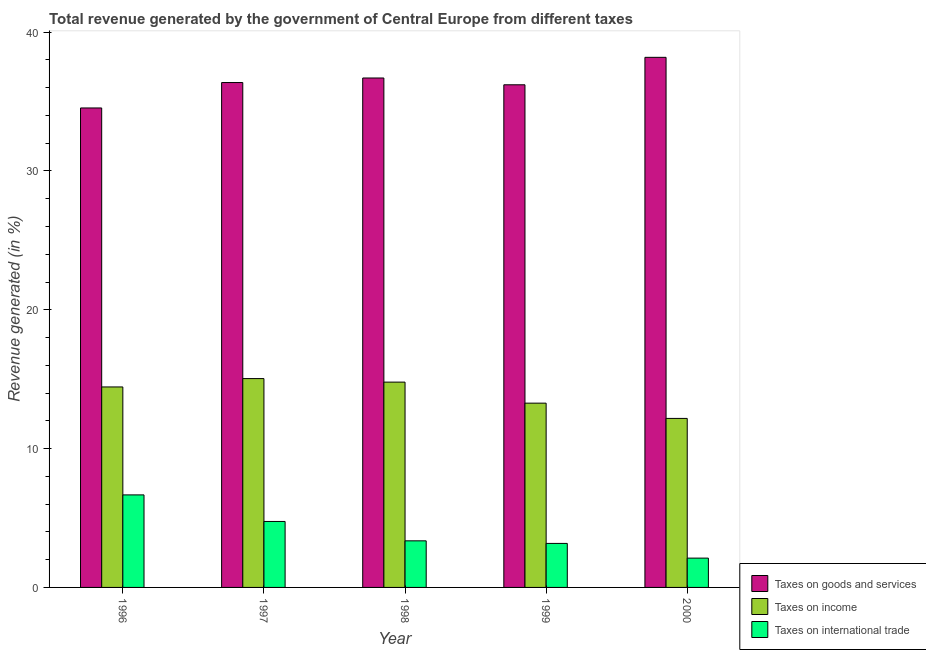How many different coloured bars are there?
Your answer should be compact. 3. Are the number of bars per tick equal to the number of legend labels?
Make the answer very short. Yes. How many bars are there on the 1st tick from the left?
Your answer should be very brief. 3. How many bars are there on the 3rd tick from the right?
Give a very brief answer. 3. What is the percentage of revenue generated by taxes on goods and services in 1996?
Ensure brevity in your answer.  34.54. Across all years, what is the maximum percentage of revenue generated by tax on international trade?
Your answer should be very brief. 6.67. Across all years, what is the minimum percentage of revenue generated by tax on international trade?
Keep it short and to the point. 2.11. In which year was the percentage of revenue generated by taxes on income maximum?
Provide a short and direct response. 1997. What is the total percentage of revenue generated by taxes on income in the graph?
Provide a short and direct response. 69.73. What is the difference between the percentage of revenue generated by taxes on income in 1996 and that in 1998?
Ensure brevity in your answer.  -0.35. What is the difference between the percentage of revenue generated by taxes on income in 1996 and the percentage of revenue generated by taxes on goods and services in 1998?
Keep it short and to the point. -0.35. What is the average percentage of revenue generated by taxes on income per year?
Give a very brief answer. 13.95. What is the ratio of the percentage of revenue generated by taxes on income in 1998 to that in 1999?
Give a very brief answer. 1.11. Is the percentage of revenue generated by taxes on goods and services in 1996 less than that in 2000?
Provide a short and direct response. Yes. What is the difference between the highest and the second highest percentage of revenue generated by taxes on income?
Provide a succinct answer. 0.25. What is the difference between the highest and the lowest percentage of revenue generated by tax on international trade?
Keep it short and to the point. 4.55. In how many years, is the percentage of revenue generated by taxes on income greater than the average percentage of revenue generated by taxes on income taken over all years?
Keep it short and to the point. 3. What does the 2nd bar from the left in 1998 represents?
Your answer should be compact. Taxes on income. What does the 3rd bar from the right in 1996 represents?
Offer a terse response. Taxes on goods and services. Are all the bars in the graph horizontal?
Offer a terse response. No. How many years are there in the graph?
Your response must be concise. 5. Are the values on the major ticks of Y-axis written in scientific E-notation?
Provide a short and direct response. No. Does the graph contain any zero values?
Keep it short and to the point. No. Does the graph contain grids?
Offer a terse response. No. How many legend labels are there?
Your answer should be very brief. 3. What is the title of the graph?
Make the answer very short. Total revenue generated by the government of Central Europe from different taxes. What is the label or title of the Y-axis?
Give a very brief answer. Revenue generated (in %). What is the Revenue generated (in %) in Taxes on goods and services in 1996?
Give a very brief answer. 34.54. What is the Revenue generated (in %) of Taxes on income in 1996?
Provide a succinct answer. 14.44. What is the Revenue generated (in %) of Taxes on international trade in 1996?
Your answer should be very brief. 6.67. What is the Revenue generated (in %) in Taxes on goods and services in 1997?
Make the answer very short. 36.37. What is the Revenue generated (in %) of Taxes on income in 1997?
Your answer should be compact. 15.04. What is the Revenue generated (in %) in Taxes on international trade in 1997?
Make the answer very short. 4.75. What is the Revenue generated (in %) of Taxes on goods and services in 1998?
Keep it short and to the point. 36.7. What is the Revenue generated (in %) in Taxes on income in 1998?
Offer a terse response. 14.79. What is the Revenue generated (in %) in Taxes on international trade in 1998?
Provide a succinct answer. 3.36. What is the Revenue generated (in %) of Taxes on goods and services in 1999?
Provide a succinct answer. 36.21. What is the Revenue generated (in %) in Taxes on income in 1999?
Your answer should be compact. 13.27. What is the Revenue generated (in %) of Taxes on international trade in 1999?
Offer a very short reply. 3.17. What is the Revenue generated (in %) in Taxes on goods and services in 2000?
Keep it short and to the point. 38.19. What is the Revenue generated (in %) in Taxes on income in 2000?
Ensure brevity in your answer.  12.18. What is the Revenue generated (in %) of Taxes on international trade in 2000?
Make the answer very short. 2.11. Across all years, what is the maximum Revenue generated (in %) in Taxes on goods and services?
Offer a very short reply. 38.19. Across all years, what is the maximum Revenue generated (in %) of Taxes on income?
Ensure brevity in your answer.  15.04. Across all years, what is the maximum Revenue generated (in %) in Taxes on international trade?
Offer a very short reply. 6.67. Across all years, what is the minimum Revenue generated (in %) of Taxes on goods and services?
Provide a short and direct response. 34.54. Across all years, what is the minimum Revenue generated (in %) of Taxes on income?
Provide a short and direct response. 12.18. Across all years, what is the minimum Revenue generated (in %) of Taxes on international trade?
Keep it short and to the point. 2.11. What is the total Revenue generated (in %) of Taxes on goods and services in the graph?
Make the answer very short. 182.01. What is the total Revenue generated (in %) of Taxes on income in the graph?
Make the answer very short. 69.73. What is the total Revenue generated (in %) of Taxes on international trade in the graph?
Your response must be concise. 20.06. What is the difference between the Revenue generated (in %) in Taxes on goods and services in 1996 and that in 1997?
Offer a very short reply. -1.83. What is the difference between the Revenue generated (in %) in Taxes on income in 1996 and that in 1997?
Your answer should be very brief. -0.6. What is the difference between the Revenue generated (in %) of Taxes on international trade in 1996 and that in 1997?
Keep it short and to the point. 1.91. What is the difference between the Revenue generated (in %) of Taxes on goods and services in 1996 and that in 1998?
Offer a terse response. -2.16. What is the difference between the Revenue generated (in %) of Taxes on income in 1996 and that in 1998?
Keep it short and to the point. -0.35. What is the difference between the Revenue generated (in %) of Taxes on international trade in 1996 and that in 1998?
Offer a terse response. 3.31. What is the difference between the Revenue generated (in %) in Taxes on goods and services in 1996 and that in 1999?
Your answer should be compact. -1.67. What is the difference between the Revenue generated (in %) of Taxes on income in 1996 and that in 1999?
Give a very brief answer. 1.17. What is the difference between the Revenue generated (in %) in Taxes on international trade in 1996 and that in 1999?
Ensure brevity in your answer.  3.5. What is the difference between the Revenue generated (in %) in Taxes on goods and services in 1996 and that in 2000?
Provide a succinct answer. -3.65. What is the difference between the Revenue generated (in %) in Taxes on income in 1996 and that in 2000?
Give a very brief answer. 2.27. What is the difference between the Revenue generated (in %) in Taxes on international trade in 1996 and that in 2000?
Make the answer very short. 4.55. What is the difference between the Revenue generated (in %) of Taxes on goods and services in 1997 and that in 1998?
Your answer should be very brief. -0.33. What is the difference between the Revenue generated (in %) of Taxes on income in 1997 and that in 1998?
Your answer should be very brief. 0.25. What is the difference between the Revenue generated (in %) of Taxes on international trade in 1997 and that in 1998?
Ensure brevity in your answer.  1.4. What is the difference between the Revenue generated (in %) in Taxes on goods and services in 1997 and that in 1999?
Provide a short and direct response. 0.16. What is the difference between the Revenue generated (in %) of Taxes on income in 1997 and that in 1999?
Provide a short and direct response. 1.77. What is the difference between the Revenue generated (in %) of Taxes on international trade in 1997 and that in 1999?
Give a very brief answer. 1.58. What is the difference between the Revenue generated (in %) in Taxes on goods and services in 1997 and that in 2000?
Your answer should be very brief. -1.82. What is the difference between the Revenue generated (in %) of Taxes on income in 1997 and that in 2000?
Provide a short and direct response. 2.87. What is the difference between the Revenue generated (in %) of Taxes on international trade in 1997 and that in 2000?
Provide a short and direct response. 2.64. What is the difference between the Revenue generated (in %) in Taxes on goods and services in 1998 and that in 1999?
Ensure brevity in your answer.  0.49. What is the difference between the Revenue generated (in %) in Taxes on income in 1998 and that in 1999?
Offer a terse response. 1.52. What is the difference between the Revenue generated (in %) in Taxes on international trade in 1998 and that in 1999?
Give a very brief answer. 0.19. What is the difference between the Revenue generated (in %) of Taxes on goods and services in 1998 and that in 2000?
Your answer should be very brief. -1.49. What is the difference between the Revenue generated (in %) in Taxes on income in 1998 and that in 2000?
Keep it short and to the point. 2.61. What is the difference between the Revenue generated (in %) of Taxes on international trade in 1998 and that in 2000?
Offer a terse response. 1.25. What is the difference between the Revenue generated (in %) in Taxes on goods and services in 1999 and that in 2000?
Make the answer very short. -1.98. What is the difference between the Revenue generated (in %) in Taxes on income in 1999 and that in 2000?
Provide a succinct answer. 1.1. What is the difference between the Revenue generated (in %) in Taxes on international trade in 1999 and that in 2000?
Provide a succinct answer. 1.06. What is the difference between the Revenue generated (in %) in Taxes on goods and services in 1996 and the Revenue generated (in %) in Taxes on income in 1997?
Make the answer very short. 19.5. What is the difference between the Revenue generated (in %) of Taxes on goods and services in 1996 and the Revenue generated (in %) of Taxes on international trade in 1997?
Give a very brief answer. 29.79. What is the difference between the Revenue generated (in %) of Taxes on income in 1996 and the Revenue generated (in %) of Taxes on international trade in 1997?
Provide a succinct answer. 9.69. What is the difference between the Revenue generated (in %) of Taxes on goods and services in 1996 and the Revenue generated (in %) of Taxes on income in 1998?
Your answer should be very brief. 19.75. What is the difference between the Revenue generated (in %) in Taxes on goods and services in 1996 and the Revenue generated (in %) in Taxes on international trade in 1998?
Make the answer very short. 31.18. What is the difference between the Revenue generated (in %) of Taxes on income in 1996 and the Revenue generated (in %) of Taxes on international trade in 1998?
Ensure brevity in your answer.  11.09. What is the difference between the Revenue generated (in %) of Taxes on goods and services in 1996 and the Revenue generated (in %) of Taxes on income in 1999?
Your answer should be compact. 21.27. What is the difference between the Revenue generated (in %) in Taxes on goods and services in 1996 and the Revenue generated (in %) in Taxes on international trade in 1999?
Provide a succinct answer. 31.37. What is the difference between the Revenue generated (in %) in Taxes on income in 1996 and the Revenue generated (in %) in Taxes on international trade in 1999?
Your answer should be very brief. 11.27. What is the difference between the Revenue generated (in %) in Taxes on goods and services in 1996 and the Revenue generated (in %) in Taxes on income in 2000?
Your answer should be compact. 22.36. What is the difference between the Revenue generated (in %) in Taxes on goods and services in 1996 and the Revenue generated (in %) in Taxes on international trade in 2000?
Make the answer very short. 32.43. What is the difference between the Revenue generated (in %) in Taxes on income in 1996 and the Revenue generated (in %) in Taxes on international trade in 2000?
Give a very brief answer. 12.33. What is the difference between the Revenue generated (in %) of Taxes on goods and services in 1997 and the Revenue generated (in %) of Taxes on income in 1998?
Offer a very short reply. 21.58. What is the difference between the Revenue generated (in %) in Taxes on goods and services in 1997 and the Revenue generated (in %) in Taxes on international trade in 1998?
Ensure brevity in your answer.  33.01. What is the difference between the Revenue generated (in %) of Taxes on income in 1997 and the Revenue generated (in %) of Taxes on international trade in 1998?
Provide a succinct answer. 11.69. What is the difference between the Revenue generated (in %) of Taxes on goods and services in 1997 and the Revenue generated (in %) of Taxes on income in 1999?
Keep it short and to the point. 23.1. What is the difference between the Revenue generated (in %) of Taxes on goods and services in 1997 and the Revenue generated (in %) of Taxes on international trade in 1999?
Your response must be concise. 33.2. What is the difference between the Revenue generated (in %) in Taxes on income in 1997 and the Revenue generated (in %) in Taxes on international trade in 1999?
Ensure brevity in your answer.  11.87. What is the difference between the Revenue generated (in %) in Taxes on goods and services in 1997 and the Revenue generated (in %) in Taxes on income in 2000?
Offer a terse response. 24.2. What is the difference between the Revenue generated (in %) of Taxes on goods and services in 1997 and the Revenue generated (in %) of Taxes on international trade in 2000?
Provide a succinct answer. 34.26. What is the difference between the Revenue generated (in %) of Taxes on income in 1997 and the Revenue generated (in %) of Taxes on international trade in 2000?
Make the answer very short. 12.93. What is the difference between the Revenue generated (in %) in Taxes on goods and services in 1998 and the Revenue generated (in %) in Taxes on income in 1999?
Your answer should be very brief. 23.42. What is the difference between the Revenue generated (in %) of Taxes on goods and services in 1998 and the Revenue generated (in %) of Taxes on international trade in 1999?
Give a very brief answer. 33.53. What is the difference between the Revenue generated (in %) of Taxes on income in 1998 and the Revenue generated (in %) of Taxes on international trade in 1999?
Make the answer very short. 11.62. What is the difference between the Revenue generated (in %) in Taxes on goods and services in 1998 and the Revenue generated (in %) in Taxes on income in 2000?
Offer a terse response. 24.52. What is the difference between the Revenue generated (in %) in Taxes on goods and services in 1998 and the Revenue generated (in %) in Taxes on international trade in 2000?
Keep it short and to the point. 34.59. What is the difference between the Revenue generated (in %) in Taxes on income in 1998 and the Revenue generated (in %) in Taxes on international trade in 2000?
Offer a very short reply. 12.68. What is the difference between the Revenue generated (in %) of Taxes on goods and services in 1999 and the Revenue generated (in %) of Taxes on income in 2000?
Make the answer very short. 24.03. What is the difference between the Revenue generated (in %) in Taxes on goods and services in 1999 and the Revenue generated (in %) in Taxes on international trade in 2000?
Give a very brief answer. 34.1. What is the difference between the Revenue generated (in %) of Taxes on income in 1999 and the Revenue generated (in %) of Taxes on international trade in 2000?
Provide a succinct answer. 11.16. What is the average Revenue generated (in %) of Taxes on goods and services per year?
Your response must be concise. 36.4. What is the average Revenue generated (in %) of Taxes on income per year?
Your response must be concise. 13.95. What is the average Revenue generated (in %) of Taxes on international trade per year?
Make the answer very short. 4.01. In the year 1996, what is the difference between the Revenue generated (in %) in Taxes on goods and services and Revenue generated (in %) in Taxes on income?
Your answer should be very brief. 20.1. In the year 1996, what is the difference between the Revenue generated (in %) in Taxes on goods and services and Revenue generated (in %) in Taxes on international trade?
Ensure brevity in your answer.  27.87. In the year 1996, what is the difference between the Revenue generated (in %) in Taxes on income and Revenue generated (in %) in Taxes on international trade?
Your answer should be compact. 7.78. In the year 1997, what is the difference between the Revenue generated (in %) of Taxes on goods and services and Revenue generated (in %) of Taxes on income?
Give a very brief answer. 21.33. In the year 1997, what is the difference between the Revenue generated (in %) of Taxes on goods and services and Revenue generated (in %) of Taxes on international trade?
Your answer should be compact. 31.62. In the year 1997, what is the difference between the Revenue generated (in %) in Taxes on income and Revenue generated (in %) in Taxes on international trade?
Provide a succinct answer. 10.29. In the year 1998, what is the difference between the Revenue generated (in %) of Taxes on goods and services and Revenue generated (in %) of Taxes on income?
Offer a very short reply. 21.91. In the year 1998, what is the difference between the Revenue generated (in %) in Taxes on goods and services and Revenue generated (in %) in Taxes on international trade?
Provide a short and direct response. 33.34. In the year 1998, what is the difference between the Revenue generated (in %) of Taxes on income and Revenue generated (in %) of Taxes on international trade?
Offer a terse response. 11.43. In the year 1999, what is the difference between the Revenue generated (in %) of Taxes on goods and services and Revenue generated (in %) of Taxes on income?
Your answer should be very brief. 22.93. In the year 1999, what is the difference between the Revenue generated (in %) in Taxes on goods and services and Revenue generated (in %) in Taxes on international trade?
Make the answer very short. 33.04. In the year 1999, what is the difference between the Revenue generated (in %) of Taxes on income and Revenue generated (in %) of Taxes on international trade?
Offer a terse response. 10.1. In the year 2000, what is the difference between the Revenue generated (in %) in Taxes on goods and services and Revenue generated (in %) in Taxes on income?
Make the answer very short. 26.01. In the year 2000, what is the difference between the Revenue generated (in %) in Taxes on goods and services and Revenue generated (in %) in Taxes on international trade?
Your answer should be very brief. 36.08. In the year 2000, what is the difference between the Revenue generated (in %) of Taxes on income and Revenue generated (in %) of Taxes on international trade?
Give a very brief answer. 10.06. What is the ratio of the Revenue generated (in %) in Taxes on goods and services in 1996 to that in 1997?
Provide a succinct answer. 0.95. What is the ratio of the Revenue generated (in %) in Taxes on international trade in 1996 to that in 1997?
Your answer should be compact. 1.4. What is the ratio of the Revenue generated (in %) in Taxes on income in 1996 to that in 1998?
Provide a short and direct response. 0.98. What is the ratio of the Revenue generated (in %) of Taxes on international trade in 1996 to that in 1998?
Provide a succinct answer. 1.99. What is the ratio of the Revenue generated (in %) in Taxes on goods and services in 1996 to that in 1999?
Ensure brevity in your answer.  0.95. What is the ratio of the Revenue generated (in %) of Taxes on income in 1996 to that in 1999?
Keep it short and to the point. 1.09. What is the ratio of the Revenue generated (in %) in Taxes on international trade in 1996 to that in 1999?
Give a very brief answer. 2.1. What is the ratio of the Revenue generated (in %) in Taxes on goods and services in 1996 to that in 2000?
Your answer should be compact. 0.9. What is the ratio of the Revenue generated (in %) of Taxes on income in 1996 to that in 2000?
Your answer should be compact. 1.19. What is the ratio of the Revenue generated (in %) in Taxes on international trade in 1996 to that in 2000?
Make the answer very short. 3.16. What is the ratio of the Revenue generated (in %) in Taxes on goods and services in 1997 to that in 1998?
Your response must be concise. 0.99. What is the ratio of the Revenue generated (in %) in Taxes on income in 1997 to that in 1998?
Offer a terse response. 1.02. What is the ratio of the Revenue generated (in %) in Taxes on international trade in 1997 to that in 1998?
Your answer should be very brief. 1.42. What is the ratio of the Revenue generated (in %) of Taxes on income in 1997 to that in 1999?
Provide a succinct answer. 1.13. What is the ratio of the Revenue generated (in %) in Taxes on international trade in 1997 to that in 1999?
Your response must be concise. 1.5. What is the ratio of the Revenue generated (in %) in Taxes on goods and services in 1997 to that in 2000?
Make the answer very short. 0.95. What is the ratio of the Revenue generated (in %) in Taxes on income in 1997 to that in 2000?
Offer a terse response. 1.24. What is the ratio of the Revenue generated (in %) of Taxes on international trade in 1997 to that in 2000?
Give a very brief answer. 2.25. What is the ratio of the Revenue generated (in %) of Taxes on goods and services in 1998 to that in 1999?
Your response must be concise. 1.01. What is the ratio of the Revenue generated (in %) in Taxes on income in 1998 to that in 1999?
Your response must be concise. 1.11. What is the ratio of the Revenue generated (in %) of Taxes on international trade in 1998 to that in 1999?
Your response must be concise. 1.06. What is the ratio of the Revenue generated (in %) of Taxes on goods and services in 1998 to that in 2000?
Keep it short and to the point. 0.96. What is the ratio of the Revenue generated (in %) of Taxes on income in 1998 to that in 2000?
Your response must be concise. 1.21. What is the ratio of the Revenue generated (in %) in Taxes on international trade in 1998 to that in 2000?
Your answer should be compact. 1.59. What is the ratio of the Revenue generated (in %) of Taxes on goods and services in 1999 to that in 2000?
Your response must be concise. 0.95. What is the ratio of the Revenue generated (in %) of Taxes on income in 1999 to that in 2000?
Your response must be concise. 1.09. What is the ratio of the Revenue generated (in %) of Taxes on international trade in 1999 to that in 2000?
Give a very brief answer. 1.5. What is the difference between the highest and the second highest Revenue generated (in %) of Taxes on goods and services?
Keep it short and to the point. 1.49. What is the difference between the highest and the second highest Revenue generated (in %) in Taxes on income?
Make the answer very short. 0.25. What is the difference between the highest and the second highest Revenue generated (in %) of Taxes on international trade?
Keep it short and to the point. 1.91. What is the difference between the highest and the lowest Revenue generated (in %) of Taxes on goods and services?
Your response must be concise. 3.65. What is the difference between the highest and the lowest Revenue generated (in %) in Taxes on income?
Provide a short and direct response. 2.87. What is the difference between the highest and the lowest Revenue generated (in %) in Taxes on international trade?
Provide a short and direct response. 4.55. 